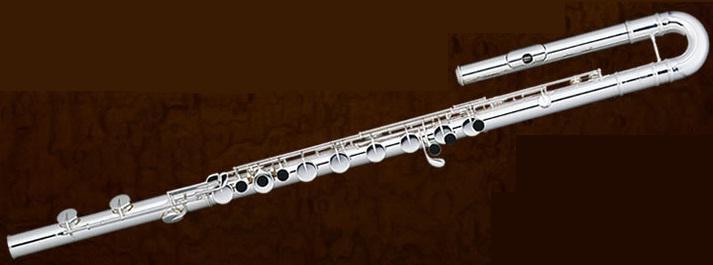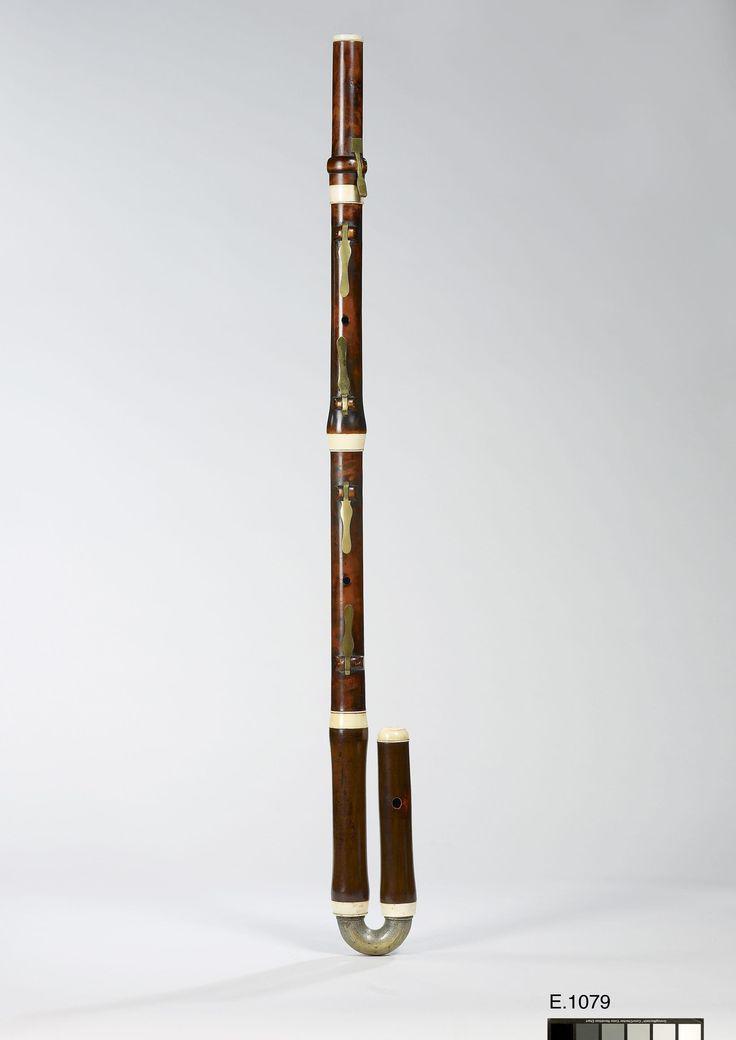The first image is the image on the left, the second image is the image on the right. For the images displayed, is the sentence "The left and right image contains the same number of hooked flutes." factually correct? Answer yes or no. Yes. The first image is the image on the left, the second image is the image on the right. Assess this claim about the two images: "There are two curved head flutes.". Correct or not? Answer yes or no. Yes. 